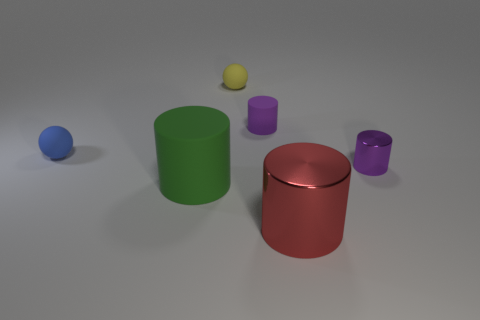Subtract all red cylinders. How many cylinders are left? 3 Add 1 big brown metal balls. How many objects exist? 7 Subtract all red cylinders. How many cylinders are left? 3 Subtract 3 cylinders. How many cylinders are left? 1 Subtract all balls. How many objects are left? 4 Subtract 0 green spheres. How many objects are left? 6 Subtract all blue cylinders. Subtract all blue spheres. How many cylinders are left? 4 Subtract all red cylinders. How many red spheres are left? 0 Subtract all big red metallic objects. Subtract all tiny green rubber blocks. How many objects are left? 5 Add 2 green things. How many green things are left? 3 